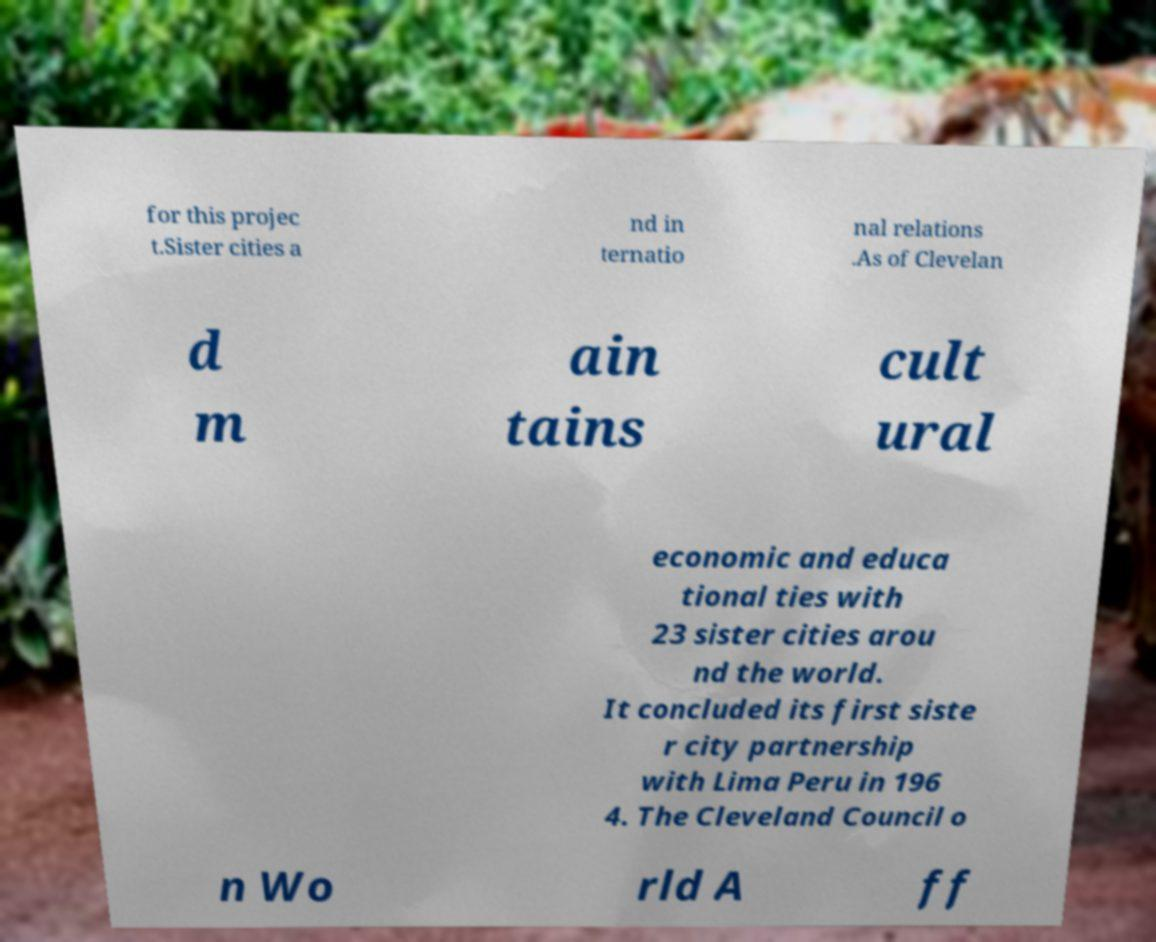Can you read and provide the text displayed in the image?This photo seems to have some interesting text. Can you extract and type it out for me? for this projec t.Sister cities a nd in ternatio nal relations .As of Clevelan d m ain tains cult ural economic and educa tional ties with 23 sister cities arou nd the world. It concluded its first siste r city partnership with Lima Peru in 196 4. The Cleveland Council o n Wo rld A ff 